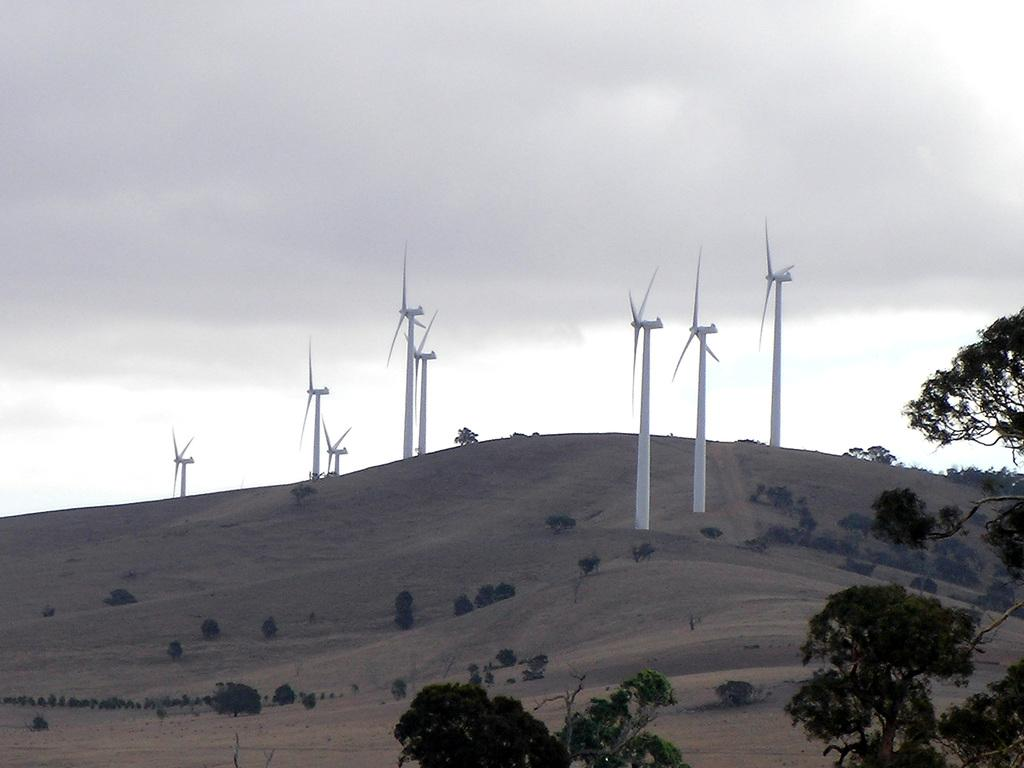What structures can be seen on the sand in the image? There are windmills on the sand in the image. What other objects are present on the sand? There are plants on the sand in the image. What can be seen to the right in the image? There are trees to the right in the image. What is visible in the back of the image? There are clouds and the sky visible in the back of the image. What type of yarn is being used to create the windmills in the image? There is no yarn present in the image; the windmills are likely made of solid materials like metal or wood. Where is the prison located in the image? There is no prison present in the image. 